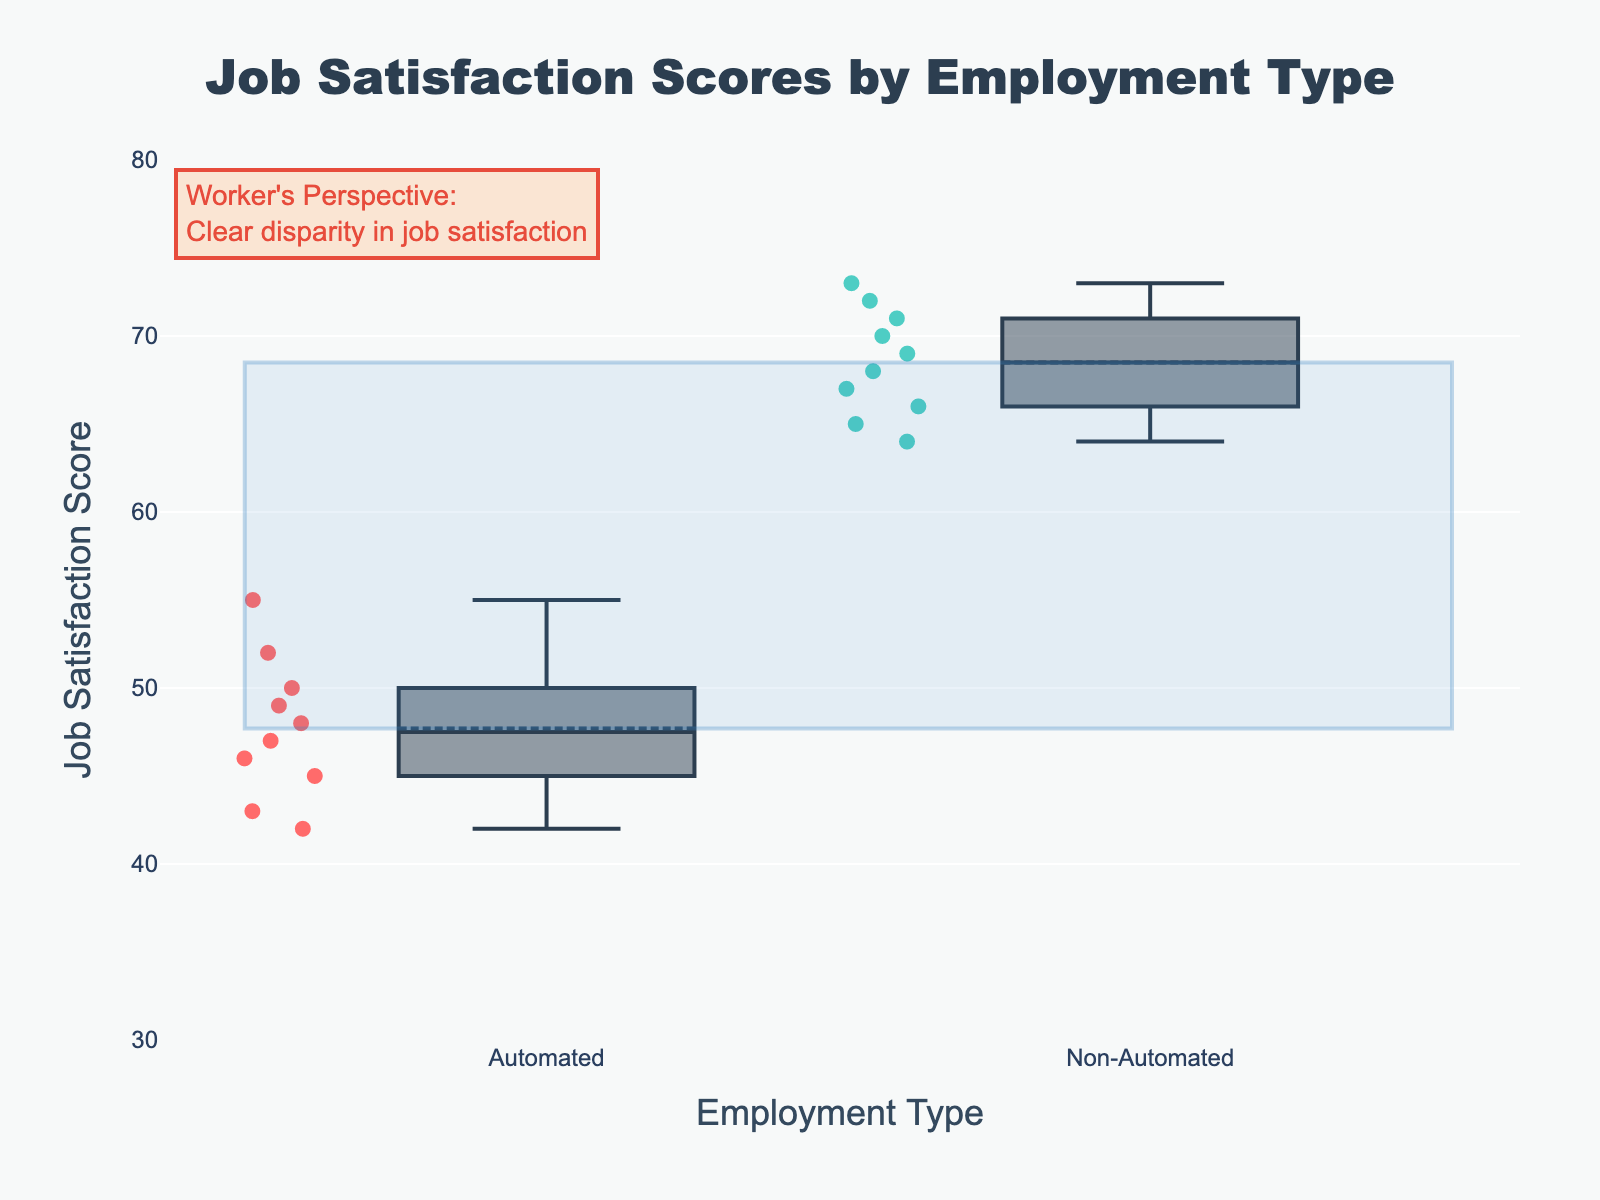What is the title of the plot? The title of the plot is displayed at the top. It is bold, large, and centered horizontally. The text reads "Job Satisfaction Scores by Employment Type."
Answer: Job Satisfaction Scores by Employment Type Which employment type has higher job satisfaction scores on average? Compare the central tendency and overall distribution of the scores in both box plots. The non-automated roles generally have higher scores with the middle line in the box situated higher than that of the automated roles.
Answer: Non-Automated Roles What are the y-axis range values for the job satisfaction scores? Look at the scale on the y-axis, the values start at 30 and go up to 80. The y-axis title indicates these values represent job satisfaction scores.
Answer: 30 to 80 How many data points are visible in each group? Count the individual dots or points in each box plot. Both automated and non-automated roles have 10 data points each, as every point represents an individual employee’s score.
Answer: 10 per group What is the median job satisfaction score for automated roles? Find the line inside the box for the automated roles and observe its position on the y-axis. The automated roles have a median value where the line is situated within the box plot.
Answer: 47 What is the maximum job satisfaction score for non-automated roles? Look for the upper whisker of the box plot for non-automated roles, which extends to the highest data point in that group. The whisker ends around at the highest score.
Answer: 73 Which job satisfaction score group has more variability? Compare the length of the boxes and whiskers. The automated group's box and whiskers are shorter, indicating less variability, while the non-automated group’s box and whiskers are longer with a broader range.
Answer: Non-Automated Roles What does the annotation in the top-left corner indicate? Read the text of the annotation. It is written in a yellow box and discusses a worker's perspective on the clear disparity in job satisfaction visible in the plot.
Answer: Clear disparity in job satisfaction How does the median job satisfaction score for automated roles compare to non-automated roles? Compare the position of the median lines inside the box plots of both groups. The median for non-automated roles is higher.
Answer: Lower in automated roles What is the range between the mean job satisfaction scores of the two employment types? Identify the highlighted rectangle’s boundaries and the average values. The gap in the mean values is the vertical distance between the top and bottom sides of the rectangle.
Answer: Difference between means 